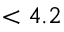<formula> <loc_0><loc_0><loc_500><loc_500>< 4 . 2</formula> 